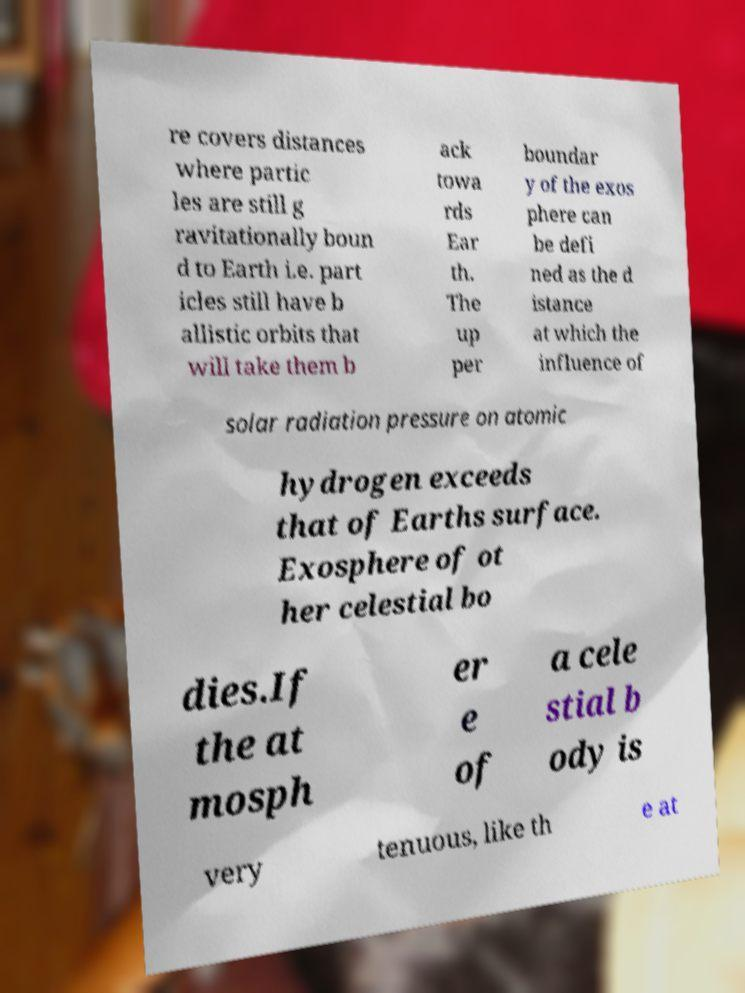Please identify and transcribe the text found in this image. re covers distances where partic les are still g ravitationally boun d to Earth i.e. part icles still have b allistic orbits that will take them b ack towa rds Ear th. The up per boundar y of the exos phere can be defi ned as the d istance at which the influence of solar radiation pressure on atomic hydrogen exceeds that of Earths surface. Exosphere of ot her celestial bo dies.If the at mosph er e of a cele stial b ody is very tenuous, like th e at 